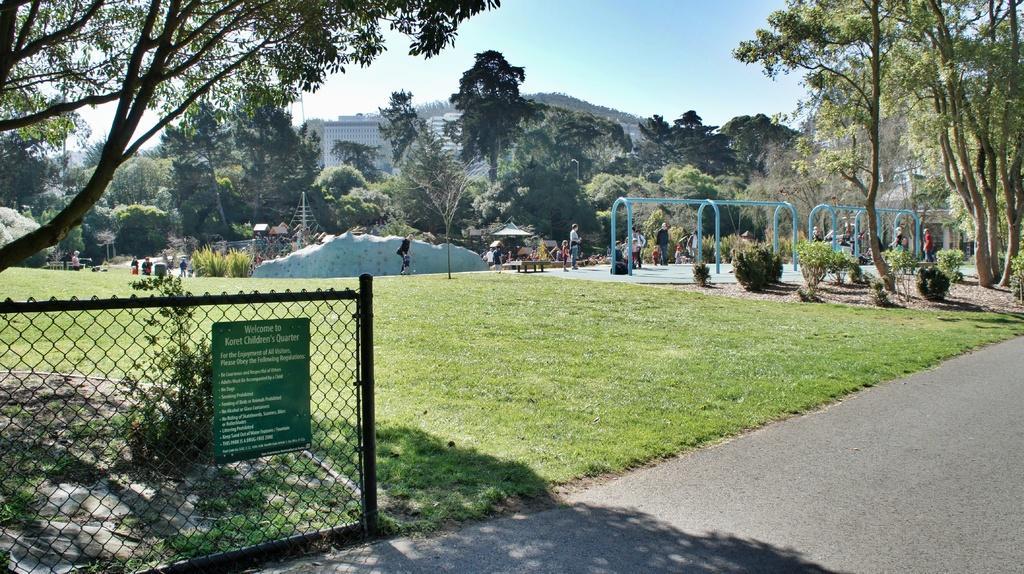Describe this image in one or two sentences. In this picture we can see road, board attached to the mesh, plants and grass. There are people and we can see rods, trees, buildings and objects. In the background of the image we can see the sky. 